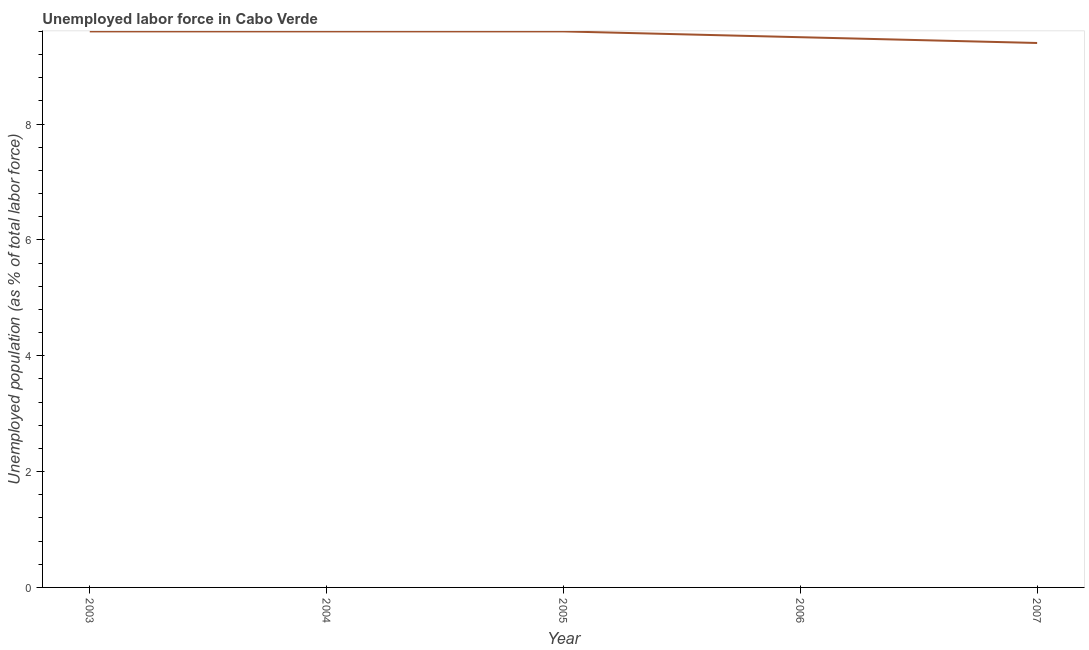What is the total unemployed population in 2003?
Provide a succinct answer. 9.6. Across all years, what is the maximum total unemployed population?
Make the answer very short. 9.6. Across all years, what is the minimum total unemployed population?
Ensure brevity in your answer.  9.4. In which year was the total unemployed population maximum?
Give a very brief answer. 2003. What is the sum of the total unemployed population?
Offer a very short reply. 47.7. What is the difference between the total unemployed population in 2003 and 2007?
Your answer should be compact. 0.2. What is the average total unemployed population per year?
Your answer should be very brief. 9.54. What is the median total unemployed population?
Your response must be concise. 9.6. What is the ratio of the total unemployed population in 2006 to that in 2007?
Provide a succinct answer. 1.01. Is the difference between the total unemployed population in 2003 and 2005 greater than the difference between any two years?
Keep it short and to the point. No. What is the difference between the highest and the second highest total unemployed population?
Provide a short and direct response. 0. What is the difference between the highest and the lowest total unemployed population?
Ensure brevity in your answer.  0.2. In how many years, is the total unemployed population greater than the average total unemployed population taken over all years?
Give a very brief answer. 3. Does the total unemployed population monotonically increase over the years?
Your response must be concise. No. How many years are there in the graph?
Provide a short and direct response. 5. What is the difference between two consecutive major ticks on the Y-axis?
Give a very brief answer. 2. Does the graph contain any zero values?
Provide a short and direct response. No. What is the title of the graph?
Your answer should be very brief. Unemployed labor force in Cabo Verde. What is the label or title of the X-axis?
Ensure brevity in your answer.  Year. What is the label or title of the Y-axis?
Your answer should be compact. Unemployed population (as % of total labor force). What is the Unemployed population (as % of total labor force) in 2003?
Ensure brevity in your answer.  9.6. What is the Unemployed population (as % of total labor force) in 2004?
Ensure brevity in your answer.  9.6. What is the Unemployed population (as % of total labor force) of 2005?
Provide a short and direct response. 9.6. What is the Unemployed population (as % of total labor force) in 2007?
Keep it short and to the point. 9.4. What is the difference between the Unemployed population (as % of total labor force) in 2003 and 2004?
Provide a succinct answer. 0. What is the difference between the Unemployed population (as % of total labor force) in 2003 and 2006?
Provide a short and direct response. 0.1. What is the difference between the Unemployed population (as % of total labor force) in 2004 and 2006?
Your response must be concise. 0.1. What is the difference between the Unemployed population (as % of total labor force) in 2004 and 2007?
Provide a succinct answer. 0.2. What is the difference between the Unemployed population (as % of total labor force) in 2005 and 2007?
Provide a succinct answer. 0.2. What is the difference between the Unemployed population (as % of total labor force) in 2006 and 2007?
Ensure brevity in your answer.  0.1. What is the ratio of the Unemployed population (as % of total labor force) in 2003 to that in 2004?
Keep it short and to the point. 1. What is the ratio of the Unemployed population (as % of total labor force) in 2003 to that in 2005?
Offer a terse response. 1. What is the ratio of the Unemployed population (as % of total labor force) in 2003 to that in 2007?
Offer a terse response. 1.02. What is the ratio of the Unemployed population (as % of total labor force) in 2004 to that in 2005?
Provide a short and direct response. 1. What is the ratio of the Unemployed population (as % of total labor force) in 2004 to that in 2006?
Keep it short and to the point. 1.01. What is the ratio of the Unemployed population (as % of total labor force) in 2005 to that in 2006?
Ensure brevity in your answer.  1.01. 